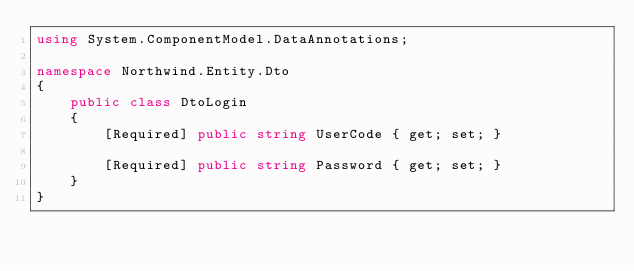Convert code to text. <code><loc_0><loc_0><loc_500><loc_500><_C#_>using System.ComponentModel.DataAnnotations;

namespace Northwind.Entity.Dto
{
    public class DtoLogin
    {
        [Required] public string UserCode { get; set; }
        
        [Required] public string Password { get; set; }
    }
}</code> 